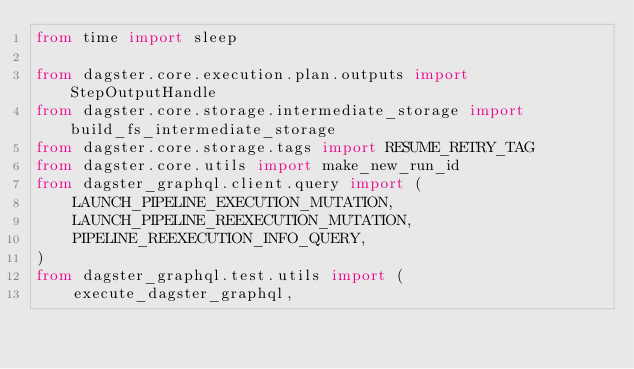<code> <loc_0><loc_0><loc_500><loc_500><_Python_>from time import sleep

from dagster.core.execution.plan.outputs import StepOutputHandle
from dagster.core.storage.intermediate_storage import build_fs_intermediate_storage
from dagster.core.storage.tags import RESUME_RETRY_TAG
from dagster.core.utils import make_new_run_id
from dagster_graphql.client.query import (
    LAUNCH_PIPELINE_EXECUTION_MUTATION,
    LAUNCH_PIPELINE_REEXECUTION_MUTATION,
    PIPELINE_REEXECUTION_INFO_QUERY,
)
from dagster_graphql.test.utils import (
    execute_dagster_graphql,</code> 